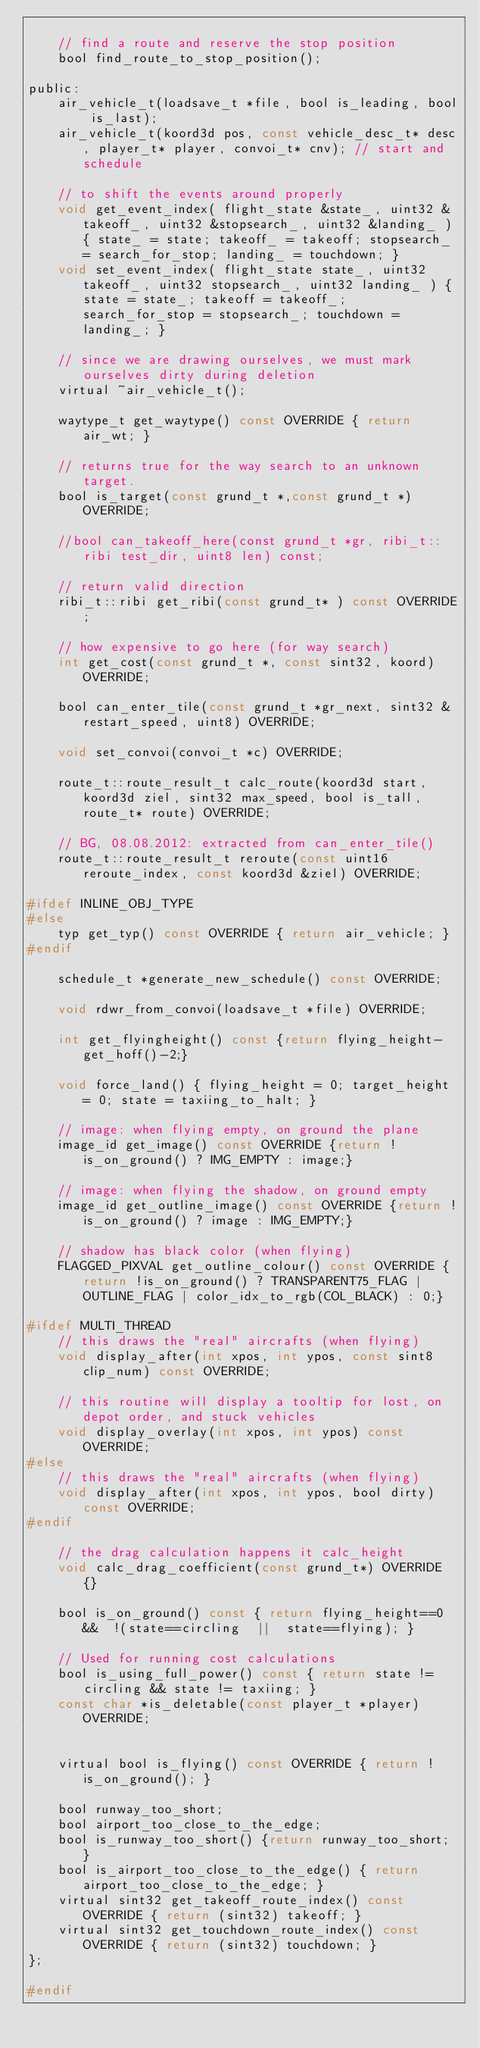<code> <loc_0><loc_0><loc_500><loc_500><_C_>
	// find a route and reserve the stop position
	bool find_route_to_stop_position();

public:
	air_vehicle_t(loadsave_t *file, bool is_leading, bool is_last);
	air_vehicle_t(koord3d pos, const vehicle_desc_t* desc, player_t* player, convoi_t* cnv); // start and schedule

	// to shift the events around properly
	void get_event_index( flight_state &state_, uint32 &takeoff_, uint32 &stopsearch_, uint32 &landing_ ) { state_ = state; takeoff_ = takeoff; stopsearch_ = search_for_stop; landing_ = touchdown; }
	void set_event_index( flight_state state_, uint32 takeoff_, uint32 stopsearch_, uint32 landing_ ) { state = state_; takeoff = takeoff_; search_for_stop = stopsearch_; touchdown = landing_; }

	// since we are drawing ourselves, we must mark ourselves dirty during deletion
	virtual ~air_vehicle_t();

	waytype_t get_waytype() const OVERRIDE { return air_wt; }

	// returns true for the way search to an unknown target.
	bool is_target(const grund_t *,const grund_t *) OVERRIDE;

	//bool can_takeoff_here(const grund_t *gr, ribi_t::ribi test_dir, uint8 len) const;

	// return valid direction
	ribi_t::ribi get_ribi(const grund_t* ) const OVERRIDE;

	// how expensive to go here (for way search)
	int get_cost(const grund_t *, const sint32, koord) OVERRIDE;

	bool can_enter_tile(const grund_t *gr_next, sint32 &restart_speed, uint8) OVERRIDE;

	void set_convoi(convoi_t *c) OVERRIDE;

	route_t::route_result_t calc_route(koord3d start, koord3d ziel, sint32 max_speed, bool is_tall, route_t* route) OVERRIDE;

	// BG, 08.08.2012: extracted from can_enter_tile()
	route_t::route_result_t reroute(const uint16 reroute_index, const koord3d &ziel) OVERRIDE;

#ifdef INLINE_OBJ_TYPE
#else
	typ get_typ() const OVERRIDE { return air_vehicle; }
#endif

	schedule_t *generate_new_schedule() const OVERRIDE;

	void rdwr_from_convoi(loadsave_t *file) OVERRIDE;

	int get_flyingheight() const {return flying_height-get_hoff()-2;}

	void force_land() { flying_height = 0; target_height = 0; state = taxiing_to_halt; }

	// image: when flying empty, on ground the plane
	image_id get_image() const OVERRIDE {return !is_on_ground() ? IMG_EMPTY : image;}

	// image: when flying the shadow, on ground empty
	image_id get_outline_image() const OVERRIDE {return !is_on_ground() ? image : IMG_EMPTY;}

	// shadow has black color (when flying)
	FLAGGED_PIXVAL get_outline_colour() const OVERRIDE {return !is_on_ground() ? TRANSPARENT75_FLAG | OUTLINE_FLAG | color_idx_to_rgb(COL_BLACK) : 0;}

#ifdef MULTI_THREAD
	// this draws the "real" aircrafts (when flying)
	void display_after(int xpos, int ypos, const sint8 clip_num) const OVERRIDE;

	// this routine will display a tooltip for lost, on depot order, and stuck vehicles
	void display_overlay(int xpos, int ypos) const OVERRIDE;
#else
	// this draws the "real" aircrafts (when flying)
	void display_after(int xpos, int ypos, bool dirty) const OVERRIDE;
#endif

	// the drag calculation happens it calc_height
	void calc_drag_coefficient(const grund_t*) OVERRIDE {}

	bool is_on_ground() const { return flying_height==0  &&  !(state==circling  ||  state==flying); }

	// Used for running cost calculations
	bool is_using_full_power() const { return state != circling && state != taxiing; }
	const char *is_deletable(const player_t *player) OVERRIDE;


	virtual bool is_flying() const OVERRIDE { return !is_on_ground(); }

	bool runway_too_short;
	bool airport_too_close_to_the_edge;
	bool is_runway_too_short() {return runway_too_short; }
	bool is_airport_too_close_to_the_edge() { return airport_too_close_to_the_edge; }
	virtual sint32 get_takeoff_route_index() const OVERRIDE { return (sint32) takeoff; }
	virtual sint32 get_touchdown_route_index() const OVERRIDE { return (sint32) touchdown; }
};

#endif
</code> 